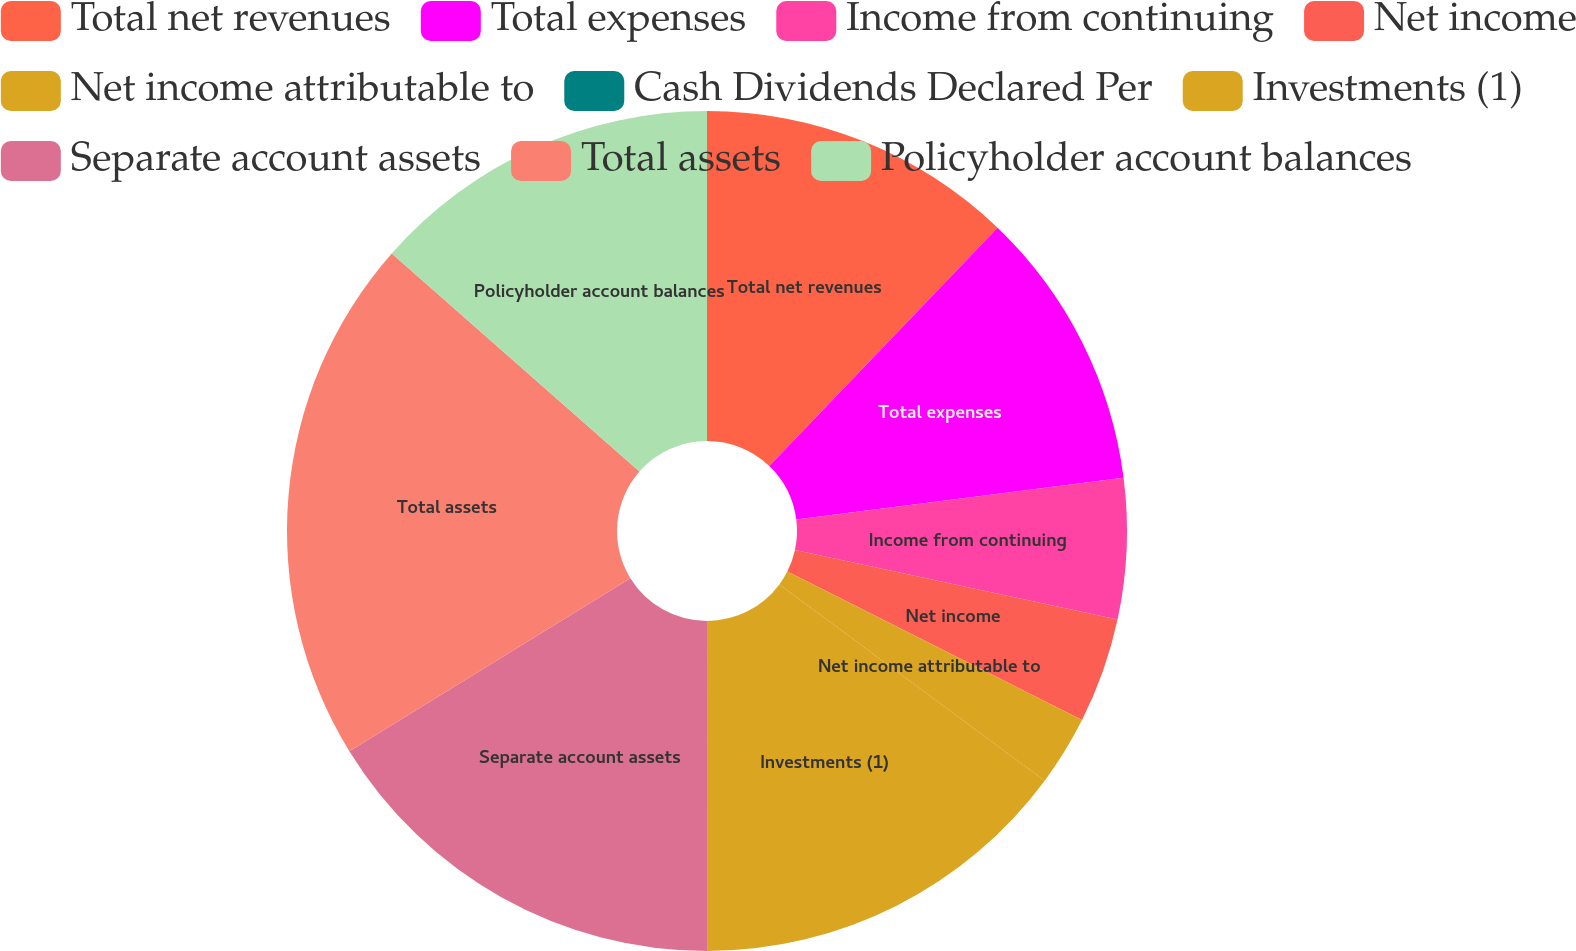Convert chart to OTSL. <chart><loc_0><loc_0><loc_500><loc_500><pie_chart><fcel>Total net revenues<fcel>Total expenses<fcel>Income from continuing<fcel>Net income<fcel>Net income attributable to<fcel>Cash Dividends Declared Per<fcel>Investments (1)<fcel>Separate account assets<fcel>Total assets<fcel>Policyholder account balances<nl><fcel>12.16%<fcel>10.81%<fcel>5.41%<fcel>4.05%<fcel>2.7%<fcel>0.0%<fcel>14.86%<fcel>16.22%<fcel>20.27%<fcel>13.51%<nl></chart> 